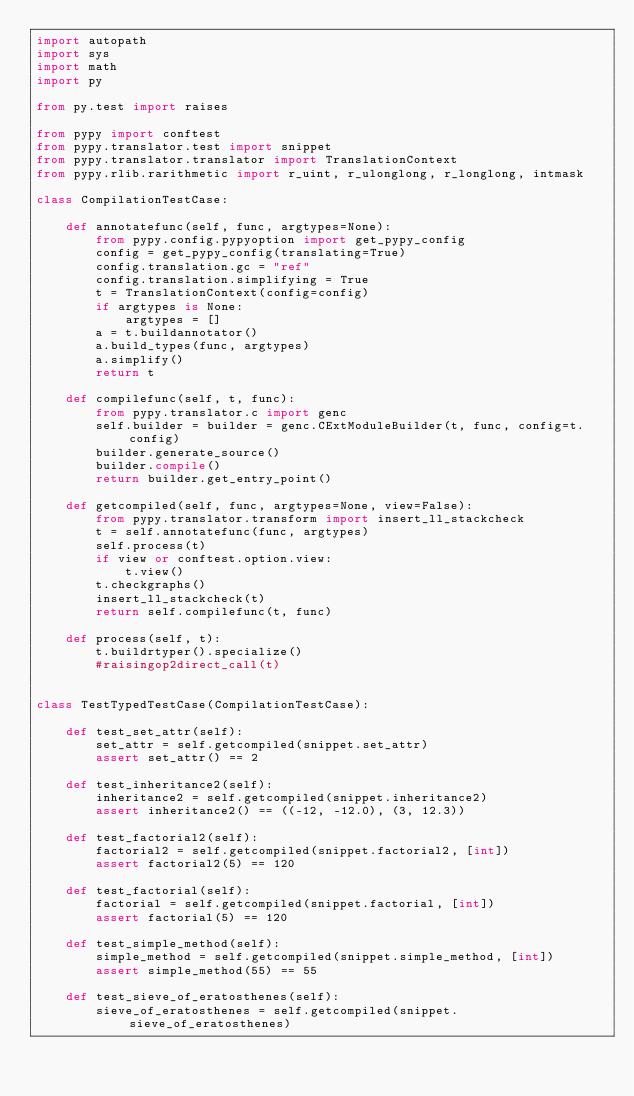Convert code to text. <code><loc_0><loc_0><loc_500><loc_500><_Python_>import autopath
import sys
import math
import py

from py.test import raises

from pypy import conftest
from pypy.translator.test import snippet
from pypy.translator.translator import TranslationContext
from pypy.rlib.rarithmetic import r_uint, r_ulonglong, r_longlong, intmask

class CompilationTestCase:

    def annotatefunc(self, func, argtypes=None):
        from pypy.config.pypyoption import get_pypy_config
        config = get_pypy_config(translating=True)
        config.translation.gc = "ref"
        config.translation.simplifying = True
        t = TranslationContext(config=config)
        if argtypes is None:
            argtypes = []
        a = t.buildannotator()
        a.build_types(func, argtypes)
        a.simplify()
        return t

    def compilefunc(self, t, func):
        from pypy.translator.c import genc
        self.builder = builder = genc.CExtModuleBuilder(t, func, config=t.config)
        builder.generate_source()
        builder.compile()
        return builder.get_entry_point()

    def getcompiled(self, func, argtypes=None, view=False):
        from pypy.translator.transform import insert_ll_stackcheck
        t = self.annotatefunc(func, argtypes)
        self.process(t)
        if view or conftest.option.view:
            t.view()
        t.checkgraphs()
        insert_ll_stackcheck(t)
        return self.compilefunc(t, func)

    def process(self, t):
        t.buildrtyper().specialize()
        #raisingop2direct_call(t)


class TestTypedTestCase(CompilationTestCase):

    def test_set_attr(self):
        set_attr = self.getcompiled(snippet.set_attr)
        assert set_attr() == 2

    def test_inheritance2(self):
        inheritance2 = self.getcompiled(snippet.inheritance2)
        assert inheritance2() == ((-12, -12.0), (3, 12.3))

    def test_factorial2(self):
        factorial2 = self.getcompiled(snippet.factorial2, [int])
        assert factorial2(5) == 120

    def test_factorial(self):
        factorial = self.getcompiled(snippet.factorial, [int])
        assert factorial(5) == 120

    def test_simple_method(self):
        simple_method = self.getcompiled(snippet.simple_method, [int])
        assert simple_method(55) == 55

    def test_sieve_of_eratosthenes(self):
        sieve_of_eratosthenes = self.getcompiled(snippet.sieve_of_eratosthenes)</code> 